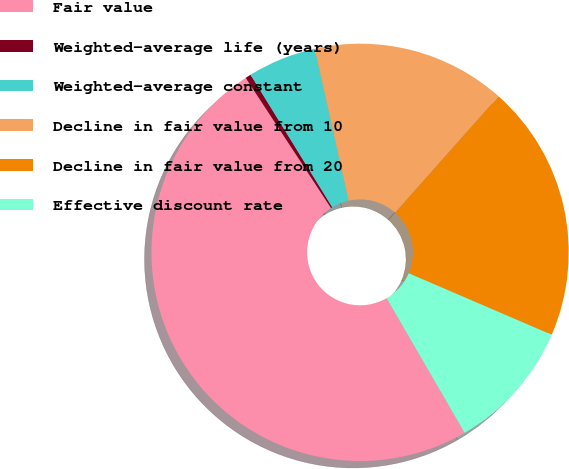Convert chart. <chart><loc_0><loc_0><loc_500><loc_500><pie_chart><fcel>Fair value<fcel>Weighted-average life (years)<fcel>Weighted-average constant<fcel>Decline in fair value from 10<fcel>Decline in fair value from 20<fcel>Effective discount rate<nl><fcel>49.12%<fcel>0.44%<fcel>5.31%<fcel>15.04%<fcel>19.91%<fcel>10.18%<nl></chart> 